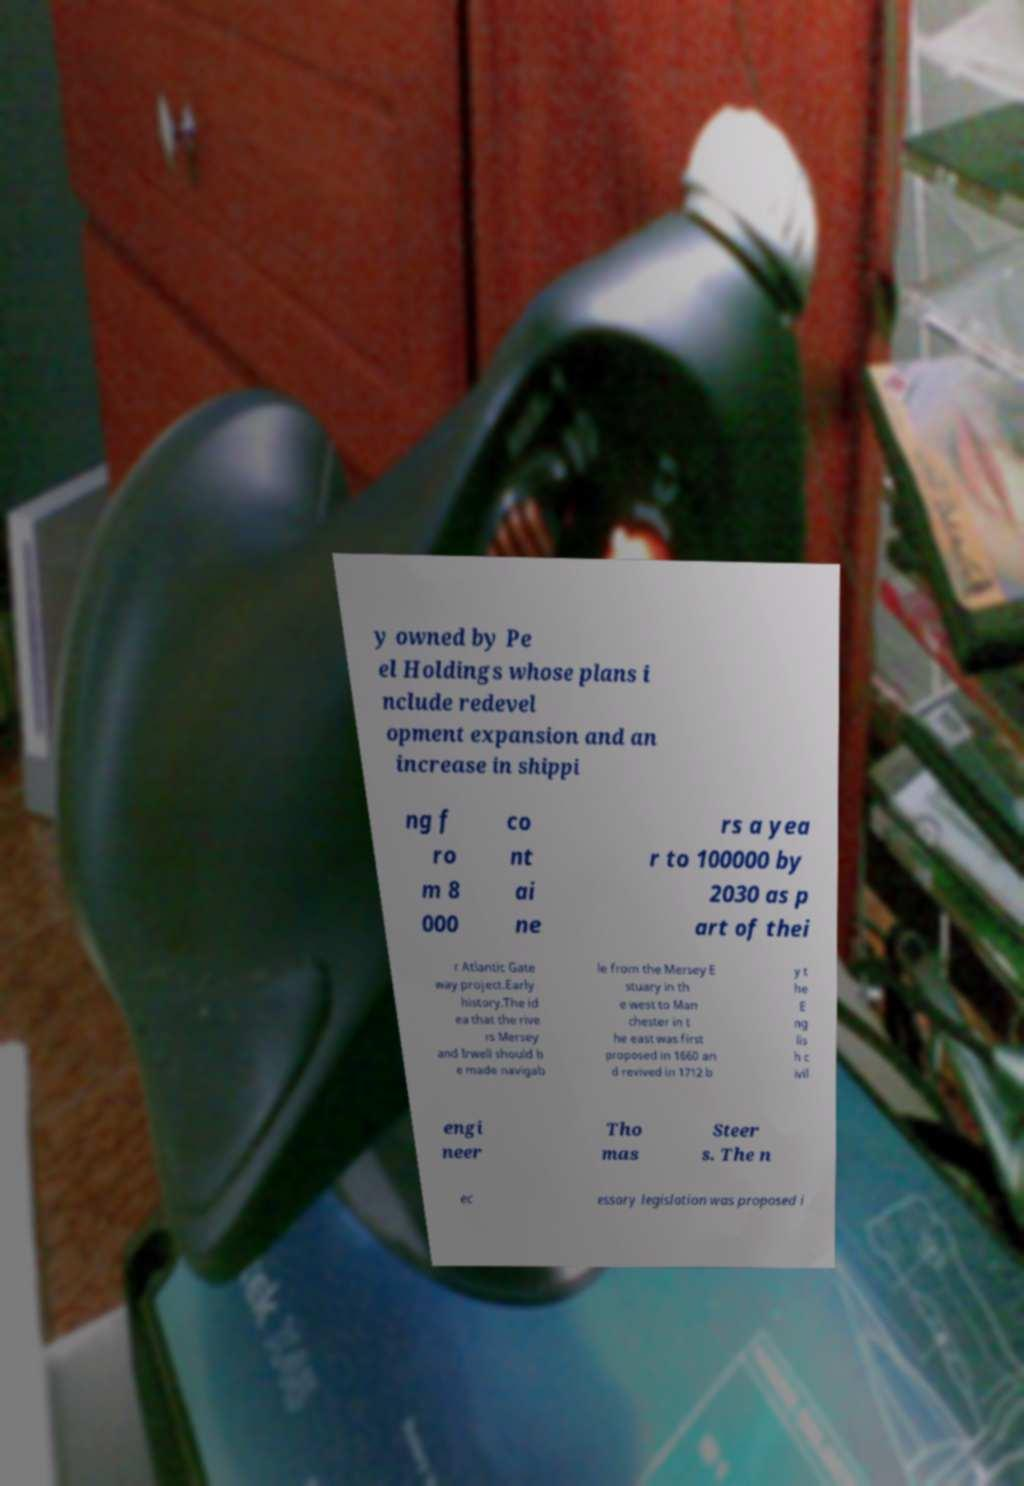I need the written content from this picture converted into text. Can you do that? y owned by Pe el Holdings whose plans i nclude redevel opment expansion and an increase in shippi ng f ro m 8 000 co nt ai ne rs a yea r to 100000 by 2030 as p art of thei r Atlantic Gate way project.Early history.The id ea that the rive rs Mersey and Irwell should b e made navigab le from the Mersey E stuary in th e west to Man chester in t he east was first proposed in 1660 an d revived in 1712 b y t he E ng lis h c ivil engi neer Tho mas Steer s. The n ec essary legislation was proposed i 